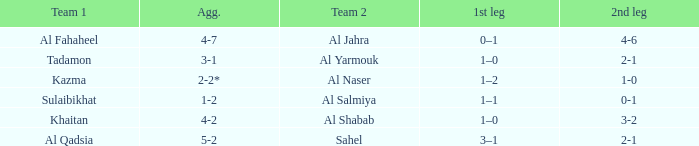If the second leg of a match finished with a 3-2 score, what was the result of the initial leg? 1–0. 